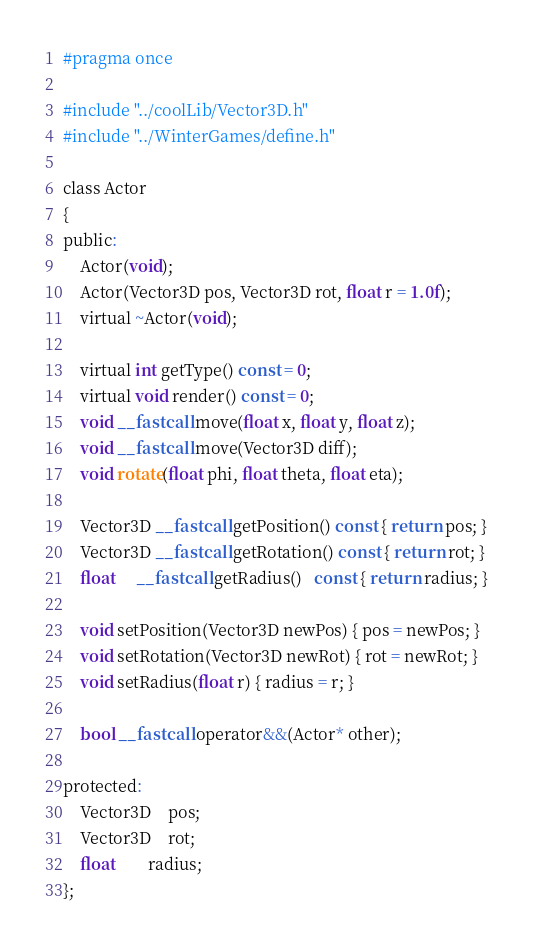<code> <loc_0><loc_0><loc_500><loc_500><_C_>#pragma once

#include "../coolLib/Vector3D.h"
#include "../WinterGames/define.h"

class Actor
{
public:
	Actor(void);
	Actor(Vector3D pos, Vector3D rot, float r = 1.0f);
	virtual ~Actor(void);

	virtual int getType() const = 0;
	virtual void render() const = 0;
	void __fastcall move(float x, float y, float z);
	void __fastcall move(Vector3D diff);
	void rotate(float phi, float theta, float eta);

	Vector3D __fastcall getPosition() const { return pos; }
	Vector3D __fastcall getRotation() const { return rot; }
	float	 __fastcall getRadius()   const { return radius; }

	void setPosition(Vector3D newPos) { pos = newPos; }
	void setRotation(Vector3D newRot) { rot = newRot; }
	void setRadius(float r) { radius = r; }

	bool __fastcall operator&&(Actor* other);

protected:
	Vector3D	pos;
	Vector3D	rot;
	float		radius;
};
</code> 